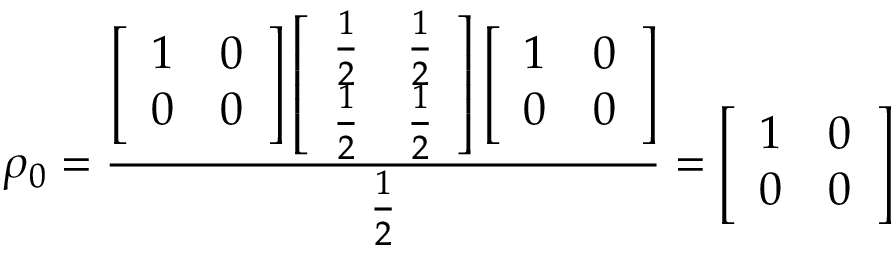Convert formula to latex. <formula><loc_0><loc_0><loc_500><loc_500>\rho _ { 0 } = \frac { \left [ \begin{array} { l l } { 1 } & { 0 } \\ { 0 } & { 0 } \end{array} \right ] \left [ \begin{array} { l l } { \frac { 1 } { 2 } } & { \frac { 1 } { 2 } } \\ { \frac { 1 } { 2 } } & { \frac { 1 } { 2 } } \end{array} \right ] \left [ \begin{array} { l l } { 1 } & { 0 } \\ { 0 } & { 0 } \end{array} \right ] } { \frac { 1 } { 2 } } = \left [ \begin{array} { l l } { 1 } & { 0 } \\ { 0 } & { 0 } \end{array} \right ]</formula> 